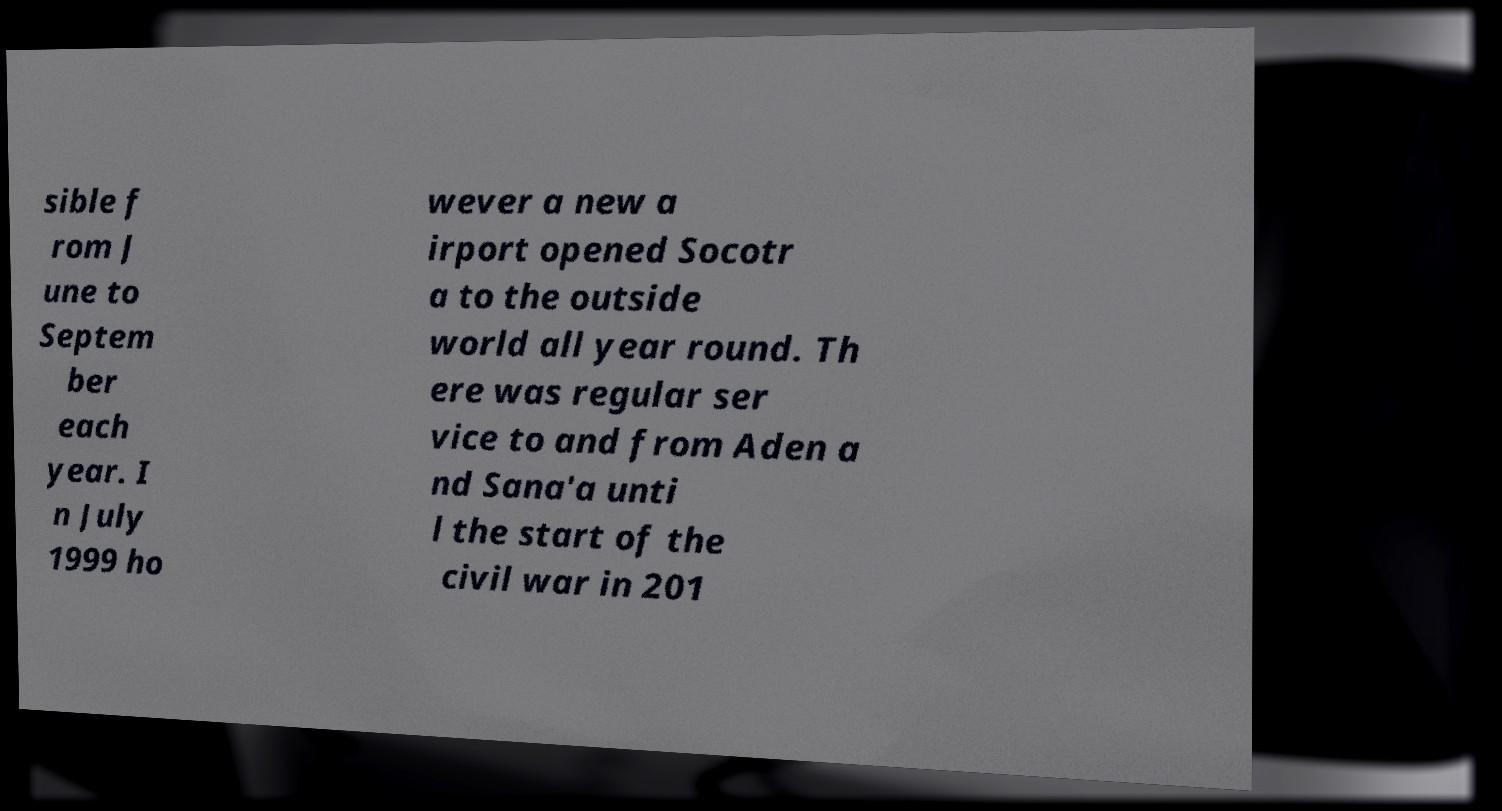Can you accurately transcribe the text from the provided image for me? sible f rom J une to Septem ber each year. I n July 1999 ho wever a new a irport opened Socotr a to the outside world all year round. Th ere was regular ser vice to and from Aden a nd Sana'a unti l the start of the civil war in 201 